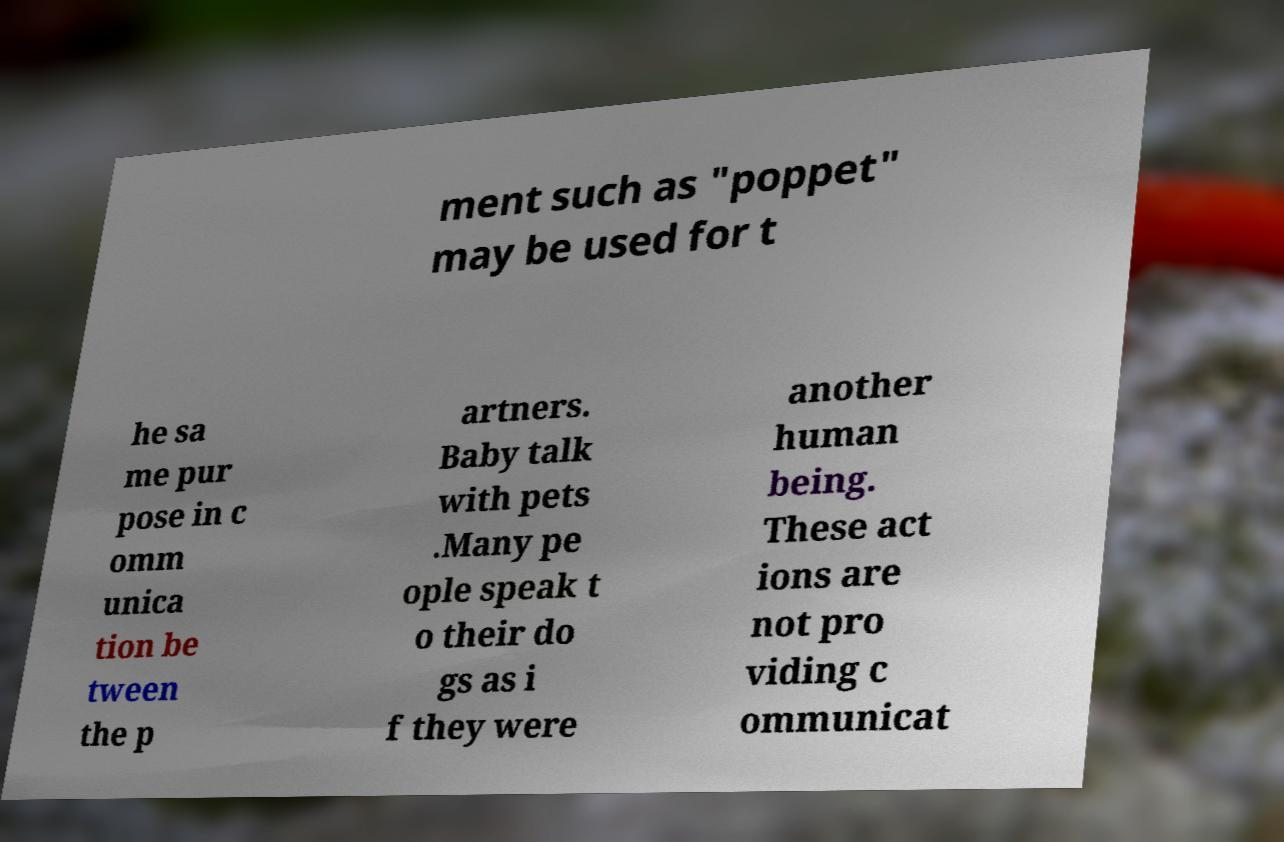Could you assist in decoding the text presented in this image and type it out clearly? ment such as "poppet" may be used for t he sa me pur pose in c omm unica tion be tween the p artners. Baby talk with pets .Many pe ople speak t o their do gs as i f they were another human being. These act ions are not pro viding c ommunicat 